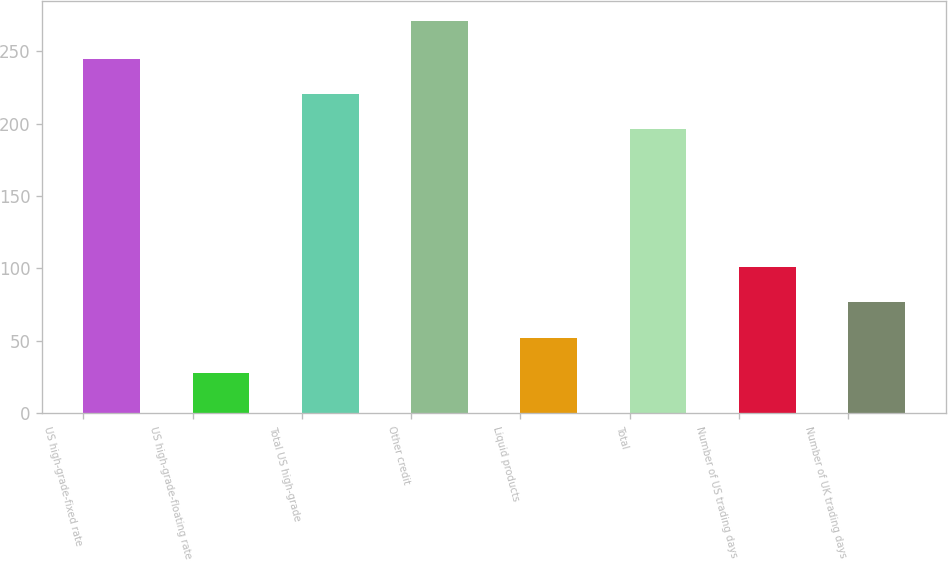Convert chart. <chart><loc_0><loc_0><loc_500><loc_500><bar_chart><fcel>US high-grade-fixed rate<fcel>US high-grade-floating rate<fcel>Total US high-grade<fcel>Other credit<fcel>Liquid products<fcel>Total<fcel>Number of US trading days<fcel>Number of UK trading days<nl><fcel>244.6<fcel>28<fcel>220.3<fcel>271<fcel>52.3<fcel>196<fcel>100.9<fcel>76.6<nl></chart> 